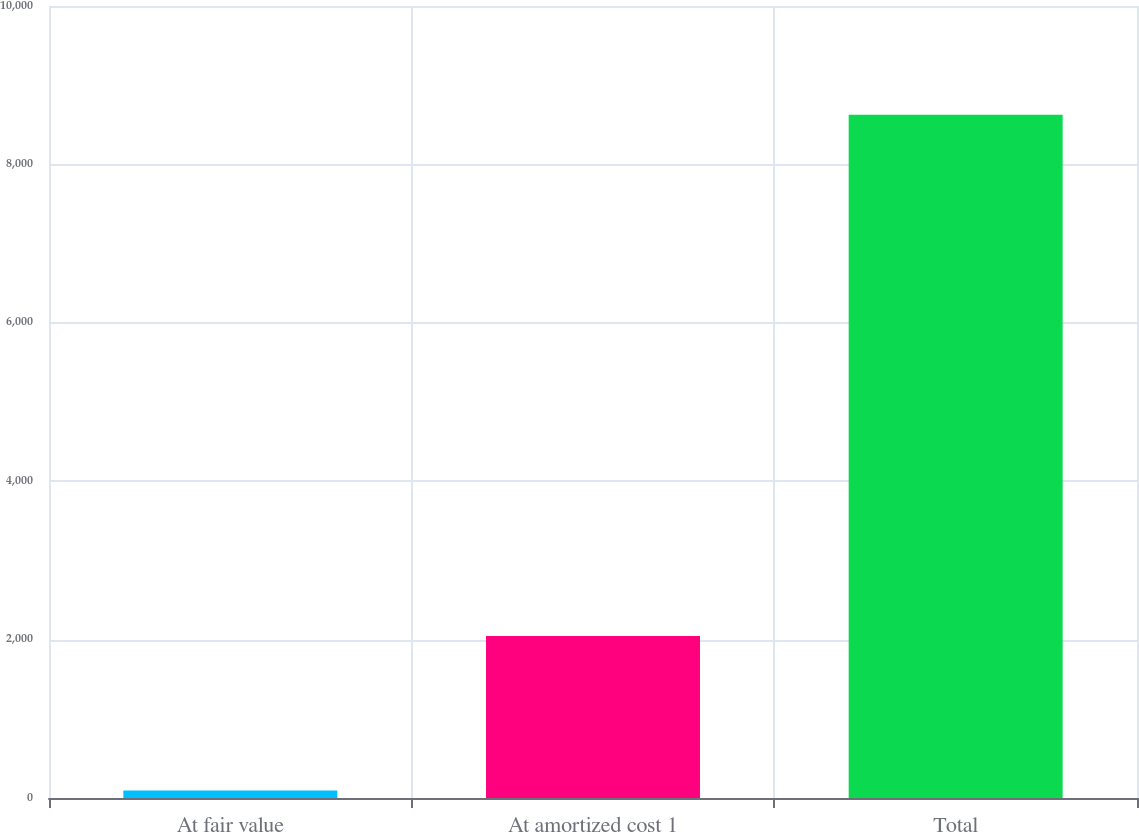Convert chart. <chart><loc_0><loc_0><loc_500><loc_500><bar_chart><fcel>At fair value<fcel>At amortized cost 1<fcel>Total<nl><fcel>94<fcel>2047<fcel>8626<nl></chart> 